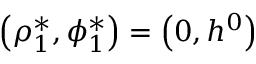<formula> <loc_0><loc_0><loc_500><loc_500>\left ( \rho _ { 1 } ^ { * } , \phi _ { 1 } ^ { * } \right ) = \left ( 0 , h ^ { 0 } \right )</formula> 